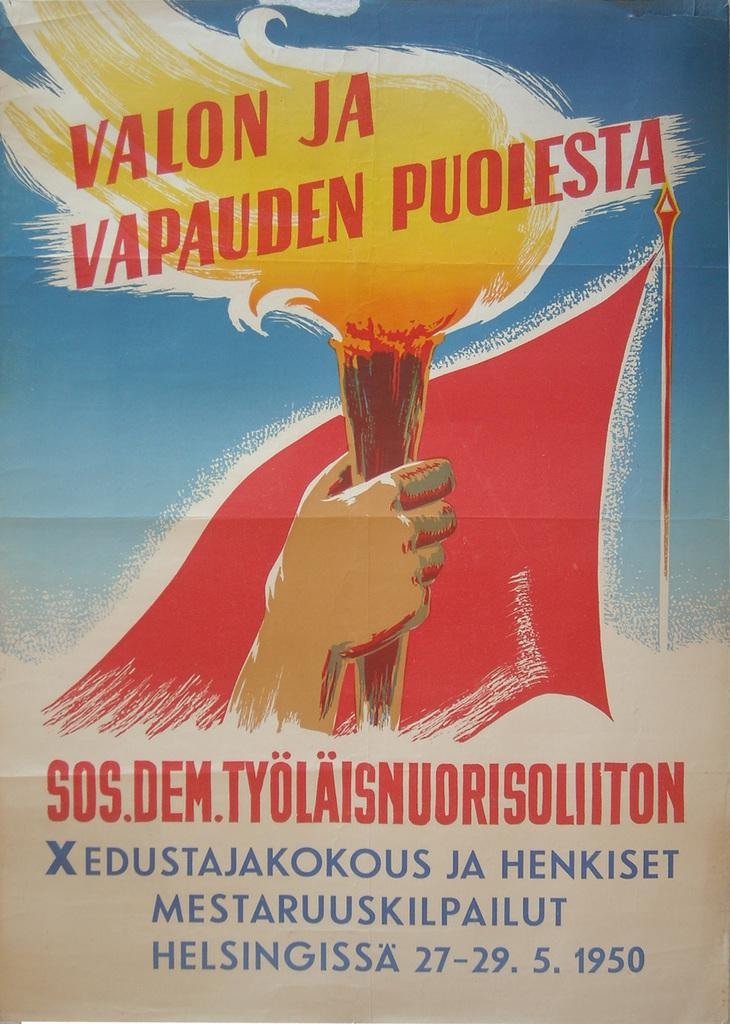<image>
Offer a succinct explanation of the picture presented. A poster for Valon Ja Vapauden Puolesta played from May 27-29 1950 